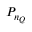Convert formula to latex. <formula><loc_0><loc_0><loc_500><loc_500>P _ { n _ { Q } }</formula> 